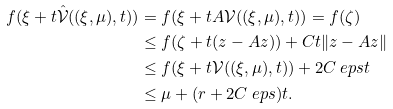Convert formula to latex. <formula><loc_0><loc_0><loc_500><loc_500>f ( \xi + t \hat { \mathcal { V } } ( ( \xi , \mu ) , t ) ) & = f ( \xi + t A { \mathcal { V } } ( ( \xi , \mu ) , t ) ) = f ( \zeta ) \\ & \leq f ( \zeta + t ( z - A z ) ) + C t \| z - A z \| \\ & \leq f ( \xi + t { \mathcal { V } } ( ( \xi , \mu ) , t ) ) + 2 C \ e p s t \\ & \leq \mu + ( r + 2 C \ e p s ) t .</formula> 